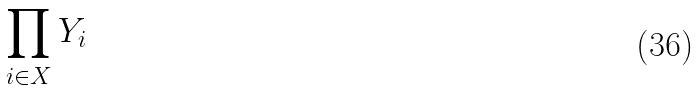<formula> <loc_0><loc_0><loc_500><loc_500>\prod _ { i \in X } Y _ { i }</formula> 